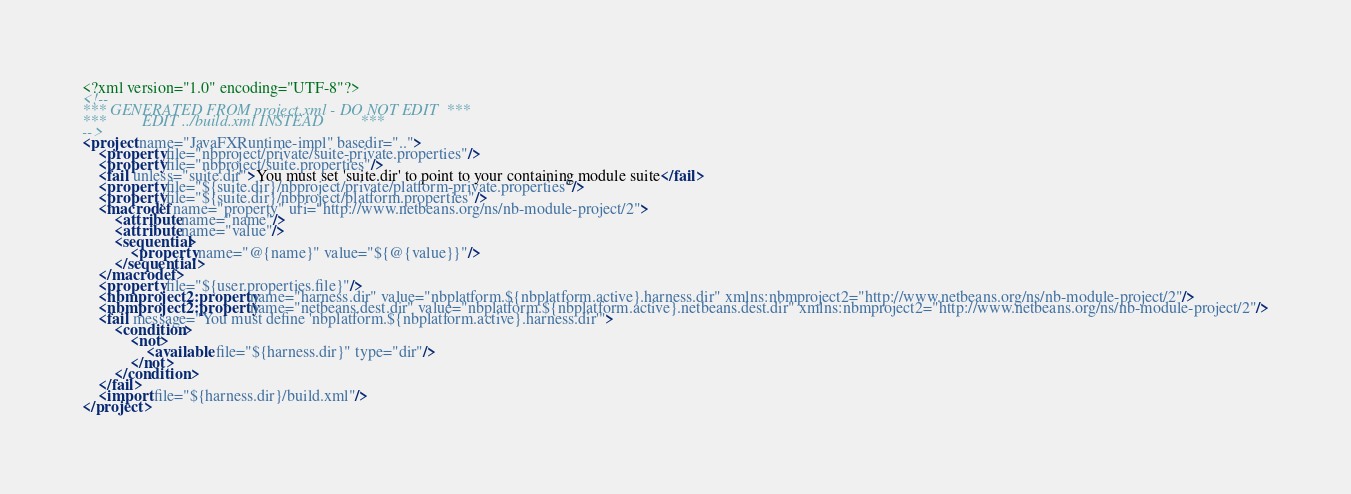<code> <loc_0><loc_0><loc_500><loc_500><_XML_><?xml version="1.0" encoding="UTF-8"?>
<!--
*** GENERATED FROM project.xml - DO NOT EDIT  ***
***         EDIT ../build.xml INSTEAD         ***
-->
<project name="JavaFXRuntime-impl" basedir="..">
    <property file="nbproject/private/suite-private.properties"/>
    <property file="nbproject/suite.properties"/>
    <fail unless="suite.dir">You must set 'suite.dir' to point to your containing module suite</fail>
    <property file="${suite.dir}/nbproject/private/platform-private.properties"/>
    <property file="${suite.dir}/nbproject/platform.properties"/>
    <macrodef name="property" uri="http://www.netbeans.org/ns/nb-module-project/2">
        <attribute name="name"/>
        <attribute name="value"/>
        <sequential>
            <property name="@{name}" value="${@{value}}"/>
        </sequential>
    </macrodef>
    <property file="${user.properties.file}"/>
    <nbmproject2:property name="harness.dir" value="nbplatform.${nbplatform.active}.harness.dir" xmlns:nbmproject2="http://www.netbeans.org/ns/nb-module-project/2"/>
    <nbmproject2:property name="netbeans.dest.dir" value="nbplatform.${nbplatform.active}.netbeans.dest.dir" xmlns:nbmproject2="http://www.netbeans.org/ns/nb-module-project/2"/>
    <fail message="You must define 'nbplatform.${nbplatform.active}.harness.dir'">
        <condition>
            <not>
                <available file="${harness.dir}" type="dir"/>
            </not>
        </condition>
    </fail>
    <import file="${harness.dir}/build.xml"/>
</project>
</code> 